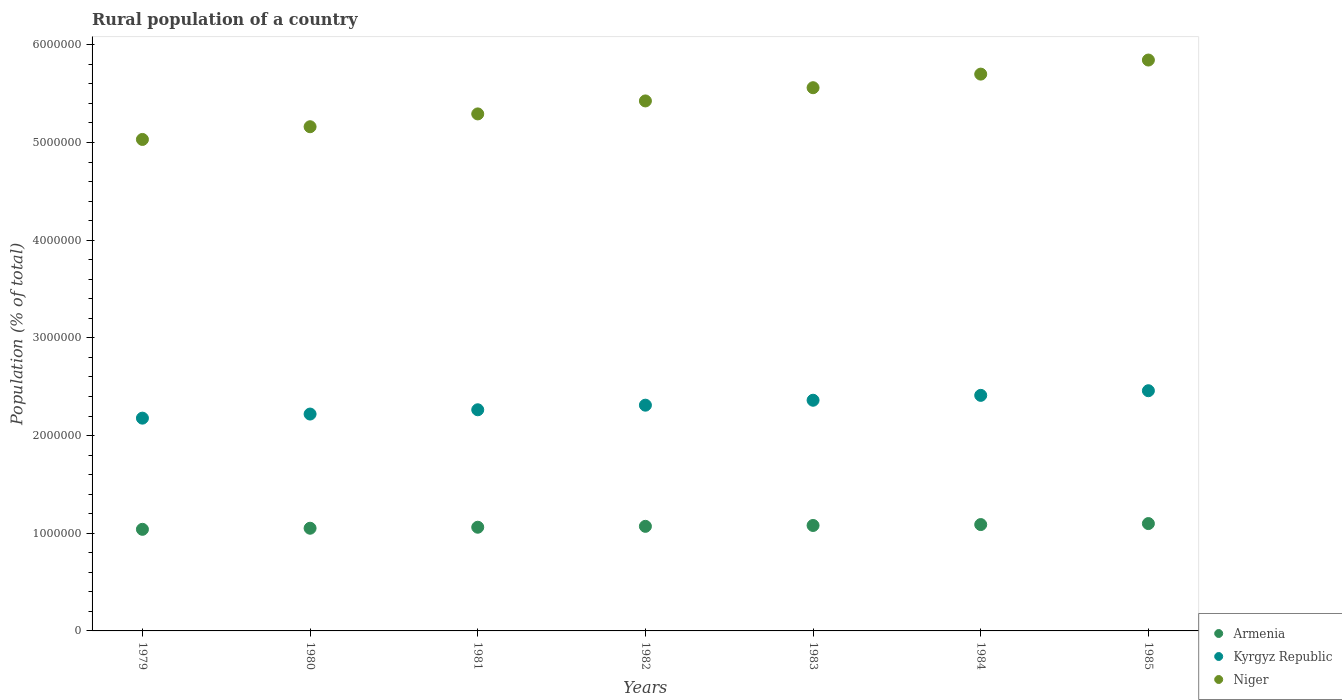Is the number of dotlines equal to the number of legend labels?
Your answer should be compact. Yes. What is the rural population in Niger in 1979?
Offer a very short reply. 5.03e+06. Across all years, what is the maximum rural population in Niger?
Offer a very short reply. 5.84e+06. Across all years, what is the minimum rural population in Armenia?
Your response must be concise. 1.04e+06. In which year was the rural population in Armenia maximum?
Your response must be concise. 1985. In which year was the rural population in Niger minimum?
Your answer should be very brief. 1979. What is the total rural population in Kyrgyz Republic in the graph?
Make the answer very short. 1.62e+07. What is the difference between the rural population in Niger in 1981 and that in 1984?
Your answer should be very brief. -4.07e+05. What is the difference between the rural population in Niger in 1979 and the rural population in Armenia in 1983?
Give a very brief answer. 3.95e+06. What is the average rural population in Kyrgyz Republic per year?
Keep it short and to the point. 2.32e+06. In the year 1979, what is the difference between the rural population in Armenia and rural population in Kyrgyz Republic?
Your answer should be very brief. -1.14e+06. What is the ratio of the rural population in Kyrgyz Republic in 1981 to that in 1983?
Your answer should be compact. 0.96. What is the difference between the highest and the second highest rural population in Niger?
Your answer should be very brief. 1.44e+05. What is the difference between the highest and the lowest rural population in Niger?
Provide a short and direct response. 8.13e+05. In how many years, is the rural population in Armenia greater than the average rural population in Armenia taken over all years?
Provide a succinct answer. 4. Is the rural population in Kyrgyz Republic strictly greater than the rural population in Niger over the years?
Your answer should be very brief. No. How many years are there in the graph?
Keep it short and to the point. 7. What is the difference between two consecutive major ticks on the Y-axis?
Your response must be concise. 1.00e+06. How many legend labels are there?
Your answer should be very brief. 3. How are the legend labels stacked?
Offer a terse response. Vertical. What is the title of the graph?
Ensure brevity in your answer.  Rural population of a country. Does "Pakistan" appear as one of the legend labels in the graph?
Provide a short and direct response. No. What is the label or title of the Y-axis?
Offer a terse response. Population (% of total). What is the Population (% of total) in Armenia in 1979?
Offer a terse response. 1.04e+06. What is the Population (% of total) of Kyrgyz Republic in 1979?
Your response must be concise. 2.18e+06. What is the Population (% of total) in Niger in 1979?
Give a very brief answer. 5.03e+06. What is the Population (% of total) in Armenia in 1980?
Provide a succinct answer. 1.05e+06. What is the Population (% of total) in Kyrgyz Republic in 1980?
Your response must be concise. 2.22e+06. What is the Population (% of total) of Niger in 1980?
Make the answer very short. 5.16e+06. What is the Population (% of total) in Armenia in 1981?
Your answer should be very brief. 1.06e+06. What is the Population (% of total) in Kyrgyz Republic in 1981?
Your answer should be very brief. 2.26e+06. What is the Population (% of total) in Niger in 1981?
Keep it short and to the point. 5.29e+06. What is the Population (% of total) in Armenia in 1982?
Your response must be concise. 1.07e+06. What is the Population (% of total) in Kyrgyz Republic in 1982?
Keep it short and to the point. 2.31e+06. What is the Population (% of total) in Niger in 1982?
Offer a terse response. 5.43e+06. What is the Population (% of total) of Armenia in 1983?
Your response must be concise. 1.08e+06. What is the Population (% of total) of Kyrgyz Republic in 1983?
Offer a very short reply. 2.36e+06. What is the Population (% of total) in Niger in 1983?
Offer a very short reply. 5.56e+06. What is the Population (% of total) of Armenia in 1984?
Provide a succinct answer. 1.09e+06. What is the Population (% of total) in Kyrgyz Republic in 1984?
Keep it short and to the point. 2.41e+06. What is the Population (% of total) in Niger in 1984?
Offer a terse response. 5.70e+06. What is the Population (% of total) of Armenia in 1985?
Your answer should be very brief. 1.10e+06. What is the Population (% of total) of Kyrgyz Republic in 1985?
Give a very brief answer. 2.46e+06. What is the Population (% of total) of Niger in 1985?
Offer a terse response. 5.84e+06. Across all years, what is the maximum Population (% of total) of Armenia?
Keep it short and to the point. 1.10e+06. Across all years, what is the maximum Population (% of total) of Kyrgyz Republic?
Provide a short and direct response. 2.46e+06. Across all years, what is the maximum Population (% of total) in Niger?
Offer a terse response. 5.84e+06. Across all years, what is the minimum Population (% of total) of Armenia?
Ensure brevity in your answer.  1.04e+06. Across all years, what is the minimum Population (% of total) of Kyrgyz Republic?
Your answer should be very brief. 2.18e+06. Across all years, what is the minimum Population (% of total) in Niger?
Provide a succinct answer. 5.03e+06. What is the total Population (% of total) of Armenia in the graph?
Your answer should be compact. 7.49e+06. What is the total Population (% of total) in Kyrgyz Republic in the graph?
Make the answer very short. 1.62e+07. What is the total Population (% of total) in Niger in the graph?
Offer a very short reply. 3.80e+07. What is the difference between the Population (% of total) of Armenia in 1979 and that in 1980?
Offer a terse response. -1.11e+04. What is the difference between the Population (% of total) of Kyrgyz Republic in 1979 and that in 1980?
Provide a succinct answer. -4.19e+04. What is the difference between the Population (% of total) in Niger in 1979 and that in 1980?
Your answer should be very brief. -1.30e+05. What is the difference between the Population (% of total) of Armenia in 1979 and that in 1981?
Offer a terse response. -2.14e+04. What is the difference between the Population (% of total) of Kyrgyz Republic in 1979 and that in 1981?
Provide a succinct answer. -8.57e+04. What is the difference between the Population (% of total) in Niger in 1979 and that in 1981?
Give a very brief answer. -2.61e+05. What is the difference between the Population (% of total) of Armenia in 1979 and that in 1982?
Offer a terse response. -3.06e+04. What is the difference between the Population (% of total) in Kyrgyz Republic in 1979 and that in 1982?
Provide a succinct answer. -1.33e+05. What is the difference between the Population (% of total) of Niger in 1979 and that in 1982?
Make the answer very short. -3.94e+05. What is the difference between the Population (% of total) in Armenia in 1979 and that in 1983?
Offer a very short reply. -3.94e+04. What is the difference between the Population (% of total) of Kyrgyz Republic in 1979 and that in 1983?
Provide a succinct answer. -1.83e+05. What is the difference between the Population (% of total) of Niger in 1979 and that in 1983?
Provide a short and direct response. -5.30e+05. What is the difference between the Population (% of total) of Armenia in 1979 and that in 1984?
Give a very brief answer. -4.87e+04. What is the difference between the Population (% of total) of Kyrgyz Republic in 1979 and that in 1984?
Give a very brief answer. -2.33e+05. What is the difference between the Population (% of total) in Niger in 1979 and that in 1984?
Make the answer very short. -6.69e+05. What is the difference between the Population (% of total) of Armenia in 1979 and that in 1985?
Your answer should be very brief. -5.89e+04. What is the difference between the Population (% of total) of Kyrgyz Republic in 1979 and that in 1985?
Your answer should be compact. -2.81e+05. What is the difference between the Population (% of total) in Niger in 1979 and that in 1985?
Offer a terse response. -8.13e+05. What is the difference between the Population (% of total) in Armenia in 1980 and that in 1981?
Provide a succinct answer. -1.03e+04. What is the difference between the Population (% of total) in Kyrgyz Republic in 1980 and that in 1981?
Your answer should be compact. -4.38e+04. What is the difference between the Population (% of total) in Niger in 1980 and that in 1981?
Make the answer very short. -1.31e+05. What is the difference between the Population (% of total) of Armenia in 1980 and that in 1982?
Make the answer very short. -1.95e+04. What is the difference between the Population (% of total) in Kyrgyz Republic in 1980 and that in 1982?
Offer a very short reply. -9.08e+04. What is the difference between the Population (% of total) in Niger in 1980 and that in 1982?
Ensure brevity in your answer.  -2.64e+05. What is the difference between the Population (% of total) of Armenia in 1980 and that in 1983?
Your answer should be compact. -2.83e+04. What is the difference between the Population (% of total) in Kyrgyz Republic in 1980 and that in 1983?
Offer a very short reply. -1.41e+05. What is the difference between the Population (% of total) of Niger in 1980 and that in 1983?
Your answer should be compact. -3.99e+05. What is the difference between the Population (% of total) in Armenia in 1980 and that in 1984?
Offer a very short reply. -3.76e+04. What is the difference between the Population (% of total) in Kyrgyz Republic in 1980 and that in 1984?
Your response must be concise. -1.91e+05. What is the difference between the Population (% of total) in Niger in 1980 and that in 1984?
Make the answer very short. -5.39e+05. What is the difference between the Population (% of total) in Armenia in 1980 and that in 1985?
Offer a terse response. -4.77e+04. What is the difference between the Population (% of total) of Kyrgyz Republic in 1980 and that in 1985?
Offer a very short reply. -2.39e+05. What is the difference between the Population (% of total) in Niger in 1980 and that in 1985?
Your answer should be very brief. -6.83e+05. What is the difference between the Population (% of total) in Armenia in 1981 and that in 1982?
Your answer should be very brief. -9214. What is the difference between the Population (% of total) in Kyrgyz Republic in 1981 and that in 1982?
Your answer should be very brief. -4.70e+04. What is the difference between the Population (% of total) of Niger in 1981 and that in 1982?
Your answer should be very brief. -1.33e+05. What is the difference between the Population (% of total) in Armenia in 1981 and that in 1983?
Ensure brevity in your answer.  -1.80e+04. What is the difference between the Population (% of total) of Kyrgyz Republic in 1981 and that in 1983?
Keep it short and to the point. -9.75e+04. What is the difference between the Population (% of total) in Niger in 1981 and that in 1983?
Your response must be concise. -2.68e+05. What is the difference between the Population (% of total) in Armenia in 1981 and that in 1984?
Give a very brief answer. -2.73e+04. What is the difference between the Population (% of total) of Kyrgyz Republic in 1981 and that in 1984?
Provide a short and direct response. -1.48e+05. What is the difference between the Population (% of total) of Niger in 1981 and that in 1984?
Keep it short and to the point. -4.07e+05. What is the difference between the Population (% of total) of Armenia in 1981 and that in 1985?
Make the answer very short. -3.75e+04. What is the difference between the Population (% of total) in Kyrgyz Republic in 1981 and that in 1985?
Your answer should be very brief. -1.95e+05. What is the difference between the Population (% of total) of Niger in 1981 and that in 1985?
Provide a short and direct response. -5.51e+05. What is the difference between the Population (% of total) in Armenia in 1982 and that in 1983?
Ensure brevity in your answer.  -8800. What is the difference between the Population (% of total) in Kyrgyz Republic in 1982 and that in 1983?
Offer a very short reply. -5.05e+04. What is the difference between the Population (% of total) in Niger in 1982 and that in 1983?
Ensure brevity in your answer.  -1.35e+05. What is the difference between the Population (% of total) of Armenia in 1982 and that in 1984?
Your answer should be compact. -1.81e+04. What is the difference between the Population (% of total) of Kyrgyz Republic in 1982 and that in 1984?
Ensure brevity in your answer.  -1.00e+05. What is the difference between the Population (% of total) in Niger in 1982 and that in 1984?
Your answer should be compact. -2.74e+05. What is the difference between the Population (% of total) of Armenia in 1982 and that in 1985?
Provide a succinct answer. -2.82e+04. What is the difference between the Population (% of total) of Kyrgyz Republic in 1982 and that in 1985?
Provide a short and direct response. -1.48e+05. What is the difference between the Population (% of total) of Niger in 1982 and that in 1985?
Offer a terse response. -4.19e+05. What is the difference between the Population (% of total) of Armenia in 1983 and that in 1984?
Keep it short and to the point. -9284. What is the difference between the Population (% of total) in Kyrgyz Republic in 1983 and that in 1984?
Your answer should be very brief. -5.00e+04. What is the difference between the Population (% of total) in Niger in 1983 and that in 1984?
Keep it short and to the point. -1.39e+05. What is the difference between the Population (% of total) in Armenia in 1983 and that in 1985?
Ensure brevity in your answer.  -1.94e+04. What is the difference between the Population (% of total) of Kyrgyz Republic in 1983 and that in 1985?
Make the answer very short. -9.75e+04. What is the difference between the Population (% of total) in Niger in 1983 and that in 1985?
Make the answer very short. -2.83e+05. What is the difference between the Population (% of total) of Armenia in 1984 and that in 1985?
Provide a succinct answer. -1.02e+04. What is the difference between the Population (% of total) in Kyrgyz Republic in 1984 and that in 1985?
Provide a short and direct response. -4.75e+04. What is the difference between the Population (% of total) in Niger in 1984 and that in 1985?
Give a very brief answer. -1.44e+05. What is the difference between the Population (% of total) of Armenia in 1979 and the Population (% of total) of Kyrgyz Republic in 1980?
Keep it short and to the point. -1.18e+06. What is the difference between the Population (% of total) in Armenia in 1979 and the Population (% of total) in Niger in 1980?
Keep it short and to the point. -4.12e+06. What is the difference between the Population (% of total) of Kyrgyz Republic in 1979 and the Population (% of total) of Niger in 1980?
Give a very brief answer. -2.98e+06. What is the difference between the Population (% of total) of Armenia in 1979 and the Population (% of total) of Kyrgyz Republic in 1981?
Provide a succinct answer. -1.22e+06. What is the difference between the Population (% of total) in Armenia in 1979 and the Population (% of total) in Niger in 1981?
Give a very brief answer. -4.25e+06. What is the difference between the Population (% of total) in Kyrgyz Republic in 1979 and the Population (% of total) in Niger in 1981?
Make the answer very short. -3.11e+06. What is the difference between the Population (% of total) in Armenia in 1979 and the Population (% of total) in Kyrgyz Republic in 1982?
Make the answer very short. -1.27e+06. What is the difference between the Population (% of total) in Armenia in 1979 and the Population (% of total) in Niger in 1982?
Provide a short and direct response. -4.39e+06. What is the difference between the Population (% of total) of Kyrgyz Republic in 1979 and the Population (% of total) of Niger in 1982?
Your response must be concise. -3.25e+06. What is the difference between the Population (% of total) in Armenia in 1979 and the Population (% of total) in Kyrgyz Republic in 1983?
Keep it short and to the point. -1.32e+06. What is the difference between the Population (% of total) of Armenia in 1979 and the Population (% of total) of Niger in 1983?
Provide a succinct answer. -4.52e+06. What is the difference between the Population (% of total) of Kyrgyz Republic in 1979 and the Population (% of total) of Niger in 1983?
Provide a short and direct response. -3.38e+06. What is the difference between the Population (% of total) of Armenia in 1979 and the Population (% of total) of Kyrgyz Republic in 1984?
Keep it short and to the point. -1.37e+06. What is the difference between the Population (% of total) of Armenia in 1979 and the Population (% of total) of Niger in 1984?
Provide a short and direct response. -4.66e+06. What is the difference between the Population (% of total) in Kyrgyz Republic in 1979 and the Population (% of total) in Niger in 1984?
Your response must be concise. -3.52e+06. What is the difference between the Population (% of total) of Armenia in 1979 and the Population (% of total) of Kyrgyz Republic in 1985?
Your answer should be very brief. -1.42e+06. What is the difference between the Population (% of total) in Armenia in 1979 and the Population (% of total) in Niger in 1985?
Provide a short and direct response. -4.80e+06. What is the difference between the Population (% of total) in Kyrgyz Republic in 1979 and the Population (% of total) in Niger in 1985?
Keep it short and to the point. -3.67e+06. What is the difference between the Population (% of total) in Armenia in 1980 and the Population (% of total) in Kyrgyz Republic in 1981?
Your response must be concise. -1.21e+06. What is the difference between the Population (% of total) in Armenia in 1980 and the Population (% of total) in Niger in 1981?
Keep it short and to the point. -4.24e+06. What is the difference between the Population (% of total) of Kyrgyz Republic in 1980 and the Population (% of total) of Niger in 1981?
Offer a very short reply. -3.07e+06. What is the difference between the Population (% of total) in Armenia in 1980 and the Population (% of total) in Kyrgyz Republic in 1982?
Offer a terse response. -1.26e+06. What is the difference between the Population (% of total) in Armenia in 1980 and the Population (% of total) in Niger in 1982?
Give a very brief answer. -4.37e+06. What is the difference between the Population (% of total) in Kyrgyz Republic in 1980 and the Population (% of total) in Niger in 1982?
Your response must be concise. -3.21e+06. What is the difference between the Population (% of total) of Armenia in 1980 and the Population (% of total) of Kyrgyz Republic in 1983?
Ensure brevity in your answer.  -1.31e+06. What is the difference between the Population (% of total) of Armenia in 1980 and the Population (% of total) of Niger in 1983?
Provide a succinct answer. -4.51e+06. What is the difference between the Population (% of total) of Kyrgyz Republic in 1980 and the Population (% of total) of Niger in 1983?
Offer a very short reply. -3.34e+06. What is the difference between the Population (% of total) of Armenia in 1980 and the Population (% of total) of Kyrgyz Republic in 1984?
Provide a succinct answer. -1.36e+06. What is the difference between the Population (% of total) of Armenia in 1980 and the Population (% of total) of Niger in 1984?
Offer a terse response. -4.65e+06. What is the difference between the Population (% of total) of Kyrgyz Republic in 1980 and the Population (% of total) of Niger in 1984?
Provide a succinct answer. -3.48e+06. What is the difference between the Population (% of total) in Armenia in 1980 and the Population (% of total) in Kyrgyz Republic in 1985?
Offer a very short reply. -1.41e+06. What is the difference between the Population (% of total) of Armenia in 1980 and the Population (% of total) of Niger in 1985?
Provide a succinct answer. -4.79e+06. What is the difference between the Population (% of total) in Kyrgyz Republic in 1980 and the Population (% of total) in Niger in 1985?
Provide a succinct answer. -3.62e+06. What is the difference between the Population (% of total) of Armenia in 1981 and the Population (% of total) of Kyrgyz Republic in 1982?
Keep it short and to the point. -1.25e+06. What is the difference between the Population (% of total) of Armenia in 1981 and the Population (% of total) of Niger in 1982?
Your answer should be compact. -4.36e+06. What is the difference between the Population (% of total) of Kyrgyz Republic in 1981 and the Population (% of total) of Niger in 1982?
Provide a short and direct response. -3.16e+06. What is the difference between the Population (% of total) in Armenia in 1981 and the Population (% of total) in Kyrgyz Republic in 1983?
Keep it short and to the point. -1.30e+06. What is the difference between the Population (% of total) in Armenia in 1981 and the Population (% of total) in Niger in 1983?
Offer a terse response. -4.50e+06. What is the difference between the Population (% of total) of Kyrgyz Republic in 1981 and the Population (% of total) of Niger in 1983?
Keep it short and to the point. -3.30e+06. What is the difference between the Population (% of total) in Armenia in 1981 and the Population (% of total) in Kyrgyz Republic in 1984?
Keep it short and to the point. -1.35e+06. What is the difference between the Population (% of total) of Armenia in 1981 and the Population (% of total) of Niger in 1984?
Offer a terse response. -4.64e+06. What is the difference between the Population (% of total) of Kyrgyz Republic in 1981 and the Population (% of total) of Niger in 1984?
Give a very brief answer. -3.44e+06. What is the difference between the Population (% of total) of Armenia in 1981 and the Population (% of total) of Kyrgyz Republic in 1985?
Your answer should be very brief. -1.40e+06. What is the difference between the Population (% of total) of Armenia in 1981 and the Population (% of total) of Niger in 1985?
Offer a very short reply. -4.78e+06. What is the difference between the Population (% of total) in Kyrgyz Republic in 1981 and the Population (% of total) in Niger in 1985?
Offer a very short reply. -3.58e+06. What is the difference between the Population (% of total) of Armenia in 1982 and the Population (% of total) of Kyrgyz Republic in 1983?
Offer a very short reply. -1.29e+06. What is the difference between the Population (% of total) in Armenia in 1982 and the Population (% of total) in Niger in 1983?
Ensure brevity in your answer.  -4.49e+06. What is the difference between the Population (% of total) in Kyrgyz Republic in 1982 and the Population (% of total) in Niger in 1983?
Provide a succinct answer. -3.25e+06. What is the difference between the Population (% of total) in Armenia in 1982 and the Population (% of total) in Kyrgyz Republic in 1984?
Make the answer very short. -1.34e+06. What is the difference between the Population (% of total) in Armenia in 1982 and the Population (% of total) in Niger in 1984?
Offer a very short reply. -4.63e+06. What is the difference between the Population (% of total) in Kyrgyz Republic in 1982 and the Population (% of total) in Niger in 1984?
Make the answer very short. -3.39e+06. What is the difference between the Population (% of total) of Armenia in 1982 and the Population (% of total) of Kyrgyz Republic in 1985?
Give a very brief answer. -1.39e+06. What is the difference between the Population (% of total) in Armenia in 1982 and the Population (% of total) in Niger in 1985?
Provide a short and direct response. -4.77e+06. What is the difference between the Population (% of total) in Kyrgyz Republic in 1982 and the Population (% of total) in Niger in 1985?
Provide a short and direct response. -3.53e+06. What is the difference between the Population (% of total) of Armenia in 1983 and the Population (% of total) of Kyrgyz Republic in 1984?
Offer a terse response. -1.33e+06. What is the difference between the Population (% of total) of Armenia in 1983 and the Population (% of total) of Niger in 1984?
Ensure brevity in your answer.  -4.62e+06. What is the difference between the Population (% of total) of Kyrgyz Republic in 1983 and the Population (% of total) of Niger in 1984?
Your answer should be very brief. -3.34e+06. What is the difference between the Population (% of total) of Armenia in 1983 and the Population (% of total) of Kyrgyz Republic in 1985?
Offer a terse response. -1.38e+06. What is the difference between the Population (% of total) in Armenia in 1983 and the Population (% of total) in Niger in 1985?
Offer a very short reply. -4.76e+06. What is the difference between the Population (% of total) in Kyrgyz Republic in 1983 and the Population (% of total) in Niger in 1985?
Keep it short and to the point. -3.48e+06. What is the difference between the Population (% of total) in Armenia in 1984 and the Population (% of total) in Kyrgyz Republic in 1985?
Make the answer very short. -1.37e+06. What is the difference between the Population (% of total) in Armenia in 1984 and the Population (% of total) in Niger in 1985?
Offer a very short reply. -4.76e+06. What is the difference between the Population (% of total) of Kyrgyz Republic in 1984 and the Population (% of total) of Niger in 1985?
Offer a very short reply. -3.43e+06. What is the average Population (% of total) of Armenia per year?
Your answer should be very brief. 1.07e+06. What is the average Population (% of total) of Kyrgyz Republic per year?
Your answer should be very brief. 2.32e+06. What is the average Population (% of total) in Niger per year?
Make the answer very short. 5.43e+06. In the year 1979, what is the difference between the Population (% of total) of Armenia and Population (% of total) of Kyrgyz Republic?
Ensure brevity in your answer.  -1.14e+06. In the year 1979, what is the difference between the Population (% of total) in Armenia and Population (% of total) in Niger?
Ensure brevity in your answer.  -3.99e+06. In the year 1979, what is the difference between the Population (% of total) in Kyrgyz Republic and Population (% of total) in Niger?
Offer a very short reply. -2.85e+06. In the year 1980, what is the difference between the Population (% of total) in Armenia and Population (% of total) in Kyrgyz Republic?
Offer a very short reply. -1.17e+06. In the year 1980, what is the difference between the Population (% of total) of Armenia and Population (% of total) of Niger?
Your answer should be compact. -4.11e+06. In the year 1980, what is the difference between the Population (% of total) of Kyrgyz Republic and Population (% of total) of Niger?
Make the answer very short. -2.94e+06. In the year 1981, what is the difference between the Population (% of total) in Armenia and Population (% of total) in Kyrgyz Republic?
Make the answer very short. -1.20e+06. In the year 1981, what is the difference between the Population (% of total) of Armenia and Population (% of total) of Niger?
Make the answer very short. -4.23e+06. In the year 1981, what is the difference between the Population (% of total) of Kyrgyz Republic and Population (% of total) of Niger?
Provide a short and direct response. -3.03e+06. In the year 1982, what is the difference between the Population (% of total) of Armenia and Population (% of total) of Kyrgyz Republic?
Ensure brevity in your answer.  -1.24e+06. In the year 1982, what is the difference between the Population (% of total) of Armenia and Population (% of total) of Niger?
Your answer should be very brief. -4.35e+06. In the year 1982, what is the difference between the Population (% of total) in Kyrgyz Republic and Population (% of total) in Niger?
Make the answer very short. -3.11e+06. In the year 1983, what is the difference between the Population (% of total) of Armenia and Population (% of total) of Kyrgyz Republic?
Your answer should be compact. -1.28e+06. In the year 1983, what is the difference between the Population (% of total) in Armenia and Population (% of total) in Niger?
Provide a short and direct response. -4.48e+06. In the year 1983, what is the difference between the Population (% of total) in Kyrgyz Republic and Population (% of total) in Niger?
Keep it short and to the point. -3.20e+06. In the year 1984, what is the difference between the Population (% of total) in Armenia and Population (% of total) in Kyrgyz Republic?
Make the answer very short. -1.32e+06. In the year 1984, what is the difference between the Population (% of total) in Armenia and Population (% of total) in Niger?
Your answer should be very brief. -4.61e+06. In the year 1984, what is the difference between the Population (% of total) in Kyrgyz Republic and Population (% of total) in Niger?
Offer a terse response. -3.29e+06. In the year 1985, what is the difference between the Population (% of total) of Armenia and Population (% of total) of Kyrgyz Republic?
Your answer should be very brief. -1.36e+06. In the year 1985, what is the difference between the Population (% of total) of Armenia and Population (% of total) of Niger?
Offer a very short reply. -4.75e+06. In the year 1985, what is the difference between the Population (% of total) of Kyrgyz Republic and Population (% of total) of Niger?
Provide a short and direct response. -3.39e+06. What is the ratio of the Population (% of total) in Kyrgyz Republic in 1979 to that in 1980?
Make the answer very short. 0.98. What is the ratio of the Population (% of total) of Niger in 1979 to that in 1980?
Keep it short and to the point. 0.97. What is the ratio of the Population (% of total) in Armenia in 1979 to that in 1981?
Your response must be concise. 0.98. What is the ratio of the Population (% of total) in Kyrgyz Republic in 1979 to that in 1981?
Provide a succinct answer. 0.96. What is the ratio of the Population (% of total) in Niger in 1979 to that in 1981?
Your answer should be very brief. 0.95. What is the ratio of the Population (% of total) in Armenia in 1979 to that in 1982?
Your answer should be very brief. 0.97. What is the ratio of the Population (% of total) of Kyrgyz Republic in 1979 to that in 1982?
Offer a very short reply. 0.94. What is the ratio of the Population (% of total) in Niger in 1979 to that in 1982?
Offer a terse response. 0.93. What is the ratio of the Population (% of total) in Armenia in 1979 to that in 1983?
Your answer should be compact. 0.96. What is the ratio of the Population (% of total) of Kyrgyz Republic in 1979 to that in 1983?
Provide a short and direct response. 0.92. What is the ratio of the Population (% of total) in Niger in 1979 to that in 1983?
Provide a short and direct response. 0.9. What is the ratio of the Population (% of total) in Armenia in 1979 to that in 1984?
Your response must be concise. 0.96. What is the ratio of the Population (% of total) in Kyrgyz Republic in 1979 to that in 1984?
Give a very brief answer. 0.9. What is the ratio of the Population (% of total) of Niger in 1979 to that in 1984?
Ensure brevity in your answer.  0.88. What is the ratio of the Population (% of total) in Armenia in 1979 to that in 1985?
Keep it short and to the point. 0.95. What is the ratio of the Population (% of total) of Kyrgyz Republic in 1979 to that in 1985?
Your response must be concise. 0.89. What is the ratio of the Population (% of total) of Niger in 1979 to that in 1985?
Offer a very short reply. 0.86. What is the ratio of the Population (% of total) in Armenia in 1980 to that in 1981?
Your answer should be very brief. 0.99. What is the ratio of the Population (% of total) in Kyrgyz Republic in 1980 to that in 1981?
Provide a succinct answer. 0.98. What is the ratio of the Population (% of total) in Niger in 1980 to that in 1981?
Your answer should be compact. 0.98. What is the ratio of the Population (% of total) in Armenia in 1980 to that in 1982?
Make the answer very short. 0.98. What is the ratio of the Population (% of total) of Kyrgyz Republic in 1980 to that in 1982?
Provide a short and direct response. 0.96. What is the ratio of the Population (% of total) of Niger in 1980 to that in 1982?
Offer a terse response. 0.95. What is the ratio of the Population (% of total) of Armenia in 1980 to that in 1983?
Your answer should be compact. 0.97. What is the ratio of the Population (% of total) in Kyrgyz Republic in 1980 to that in 1983?
Your answer should be compact. 0.94. What is the ratio of the Population (% of total) of Niger in 1980 to that in 1983?
Provide a succinct answer. 0.93. What is the ratio of the Population (% of total) in Armenia in 1980 to that in 1984?
Offer a very short reply. 0.97. What is the ratio of the Population (% of total) of Kyrgyz Republic in 1980 to that in 1984?
Make the answer very short. 0.92. What is the ratio of the Population (% of total) of Niger in 1980 to that in 1984?
Your response must be concise. 0.91. What is the ratio of the Population (% of total) in Armenia in 1980 to that in 1985?
Ensure brevity in your answer.  0.96. What is the ratio of the Population (% of total) in Kyrgyz Republic in 1980 to that in 1985?
Make the answer very short. 0.9. What is the ratio of the Population (% of total) of Niger in 1980 to that in 1985?
Provide a short and direct response. 0.88. What is the ratio of the Population (% of total) of Armenia in 1981 to that in 1982?
Make the answer very short. 0.99. What is the ratio of the Population (% of total) in Kyrgyz Republic in 1981 to that in 1982?
Your response must be concise. 0.98. What is the ratio of the Population (% of total) of Niger in 1981 to that in 1982?
Keep it short and to the point. 0.98. What is the ratio of the Population (% of total) of Armenia in 1981 to that in 1983?
Ensure brevity in your answer.  0.98. What is the ratio of the Population (% of total) of Kyrgyz Republic in 1981 to that in 1983?
Offer a terse response. 0.96. What is the ratio of the Population (% of total) in Niger in 1981 to that in 1983?
Make the answer very short. 0.95. What is the ratio of the Population (% of total) of Armenia in 1981 to that in 1984?
Offer a very short reply. 0.97. What is the ratio of the Population (% of total) in Kyrgyz Republic in 1981 to that in 1984?
Make the answer very short. 0.94. What is the ratio of the Population (% of total) in Niger in 1981 to that in 1984?
Your answer should be very brief. 0.93. What is the ratio of the Population (% of total) in Armenia in 1981 to that in 1985?
Keep it short and to the point. 0.97. What is the ratio of the Population (% of total) of Kyrgyz Republic in 1981 to that in 1985?
Make the answer very short. 0.92. What is the ratio of the Population (% of total) in Niger in 1981 to that in 1985?
Offer a very short reply. 0.91. What is the ratio of the Population (% of total) in Kyrgyz Republic in 1982 to that in 1983?
Your response must be concise. 0.98. What is the ratio of the Population (% of total) of Niger in 1982 to that in 1983?
Your answer should be very brief. 0.98. What is the ratio of the Population (% of total) in Armenia in 1982 to that in 1984?
Your response must be concise. 0.98. What is the ratio of the Population (% of total) of Kyrgyz Republic in 1982 to that in 1984?
Give a very brief answer. 0.96. What is the ratio of the Population (% of total) of Niger in 1982 to that in 1984?
Your response must be concise. 0.95. What is the ratio of the Population (% of total) in Armenia in 1982 to that in 1985?
Make the answer very short. 0.97. What is the ratio of the Population (% of total) of Kyrgyz Republic in 1982 to that in 1985?
Ensure brevity in your answer.  0.94. What is the ratio of the Population (% of total) in Niger in 1982 to that in 1985?
Your response must be concise. 0.93. What is the ratio of the Population (% of total) of Kyrgyz Republic in 1983 to that in 1984?
Your answer should be very brief. 0.98. What is the ratio of the Population (% of total) of Niger in 1983 to that in 1984?
Provide a short and direct response. 0.98. What is the ratio of the Population (% of total) of Armenia in 1983 to that in 1985?
Provide a succinct answer. 0.98. What is the ratio of the Population (% of total) of Kyrgyz Republic in 1983 to that in 1985?
Your answer should be very brief. 0.96. What is the ratio of the Population (% of total) in Niger in 1983 to that in 1985?
Keep it short and to the point. 0.95. What is the ratio of the Population (% of total) of Kyrgyz Republic in 1984 to that in 1985?
Ensure brevity in your answer.  0.98. What is the ratio of the Population (% of total) in Niger in 1984 to that in 1985?
Offer a terse response. 0.98. What is the difference between the highest and the second highest Population (% of total) in Armenia?
Offer a terse response. 1.02e+04. What is the difference between the highest and the second highest Population (% of total) of Kyrgyz Republic?
Provide a succinct answer. 4.75e+04. What is the difference between the highest and the second highest Population (% of total) in Niger?
Your answer should be very brief. 1.44e+05. What is the difference between the highest and the lowest Population (% of total) of Armenia?
Keep it short and to the point. 5.89e+04. What is the difference between the highest and the lowest Population (% of total) of Kyrgyz Republic?
Provide a succinct answer. 2.81e+05. What is the difference between the highest and the lowest Population (% of total) in Niger?
Give a very brief answer. 8.13e+05. 